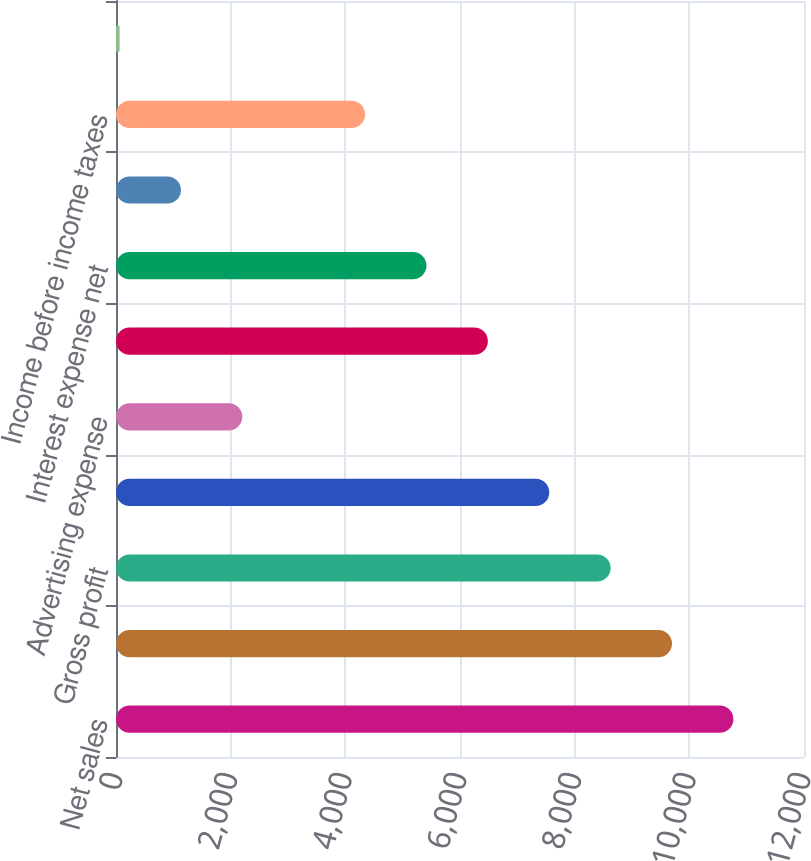Convert chart. <chart><loc_0><loc_0><loc_500><loc_500><bar_chart><fcel>Net sales<fcel>Cost of sales<fcel>Gross profit<fcel>Selling and administrative<fcel>Advertising expense<fcel>Income from operations<fcel>Interest expense net<fcel>Net loss on extinguishments of<fcel>Income before income taxes<fcel>Income tax expense<nl><fcel>10768.6<fcel>9698.01<fcel>8627.42<fcel>7556.83<fcel>2203.88<fcel>6486.24<fcel>5415.65<fcel>1133.29<fcel>4345.06<fcel>62.7<nl></chart> 